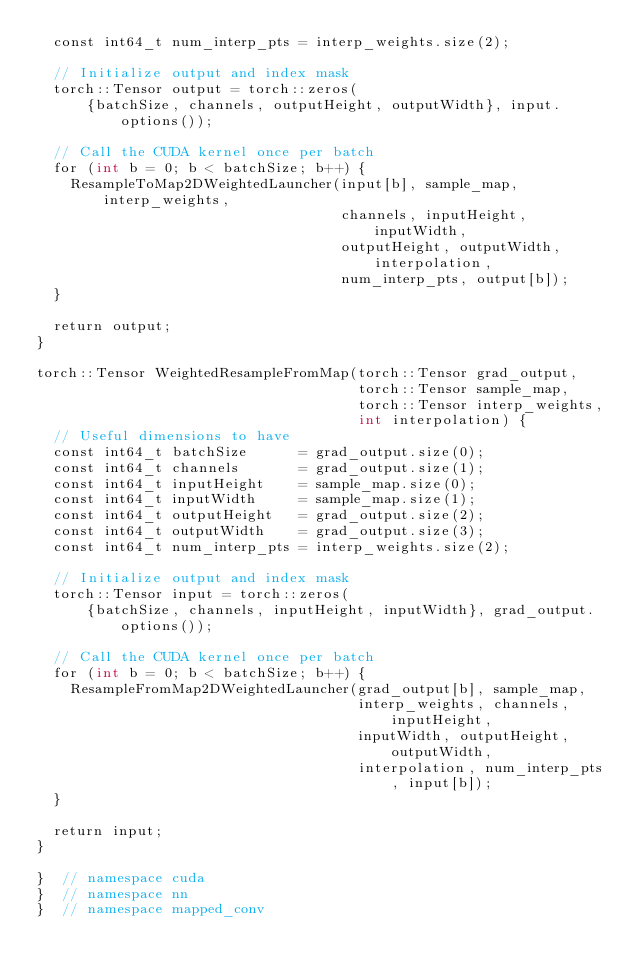<code> <loc_0><loc_0><loc_500><loc_500><_Cuda_>  const int64_t num_interp_pts = interp_weights.size(2);

  // Initialize output and index mask
  torch::Tensor output = torch::zeros(
      {batchSize, channels, outputHeight, outputWidth}, input.options());

  // Call the CUDA kernel once per batch
  for (int b = 0; b < batchSize; b++) {
    ResampleToMap2DWeightedLauncher(input[b], sample_map, interp_weights,
                                    channels, inputHeight, inputWidth,
                                    outputHeight, outputWidth, interpolation,
                                    num_interp_pts, output[b]);
  }

  return output;
}

torch::Tensor WeightedResampleFromMap(torch::Tensor grad_output,
                                      torch::Tensor sample_map,
                                      torch::Tensor interp_weights,
                                      int interpolation) {
  // Useful dimensions to have
  const int64_t batchSize      = grad_output.size(0);
  const int64_t channels       = grad_output.size(1);
  const int64_t inputHeight    = sample_map.size(0);
  const int64_t inputWidth     = sample_map.size(1);
  const int64_t outputHeight   = grad_output.size(2);
  const int64_t outputWidth    = grad_output.size(3);
  const int64_t num_interp_pts = interp_weights.size(2);

  // Initialize output and index mask
  torch::Tensor input = torch::zeros(
      {batchSize, channels, inputHeight, inputWidth}, grad_output.options());

  // Call the CUDA kernel once per batch
  for (int b = 0; b < batchSize; b++) {
    ResampleFromMap2DWeightedLauncher(grad_output[b], sample_map,
                                      interp_weights, channels, inputHeight,
                                      inputWidth, outputHeight, outputWidth,
                                      interpolation, num_interp_pts, input[b]);
  }

  return input;
}

}  // namespace cuda
}  // namespace nn
}  // namespace mapped_conv</code> 